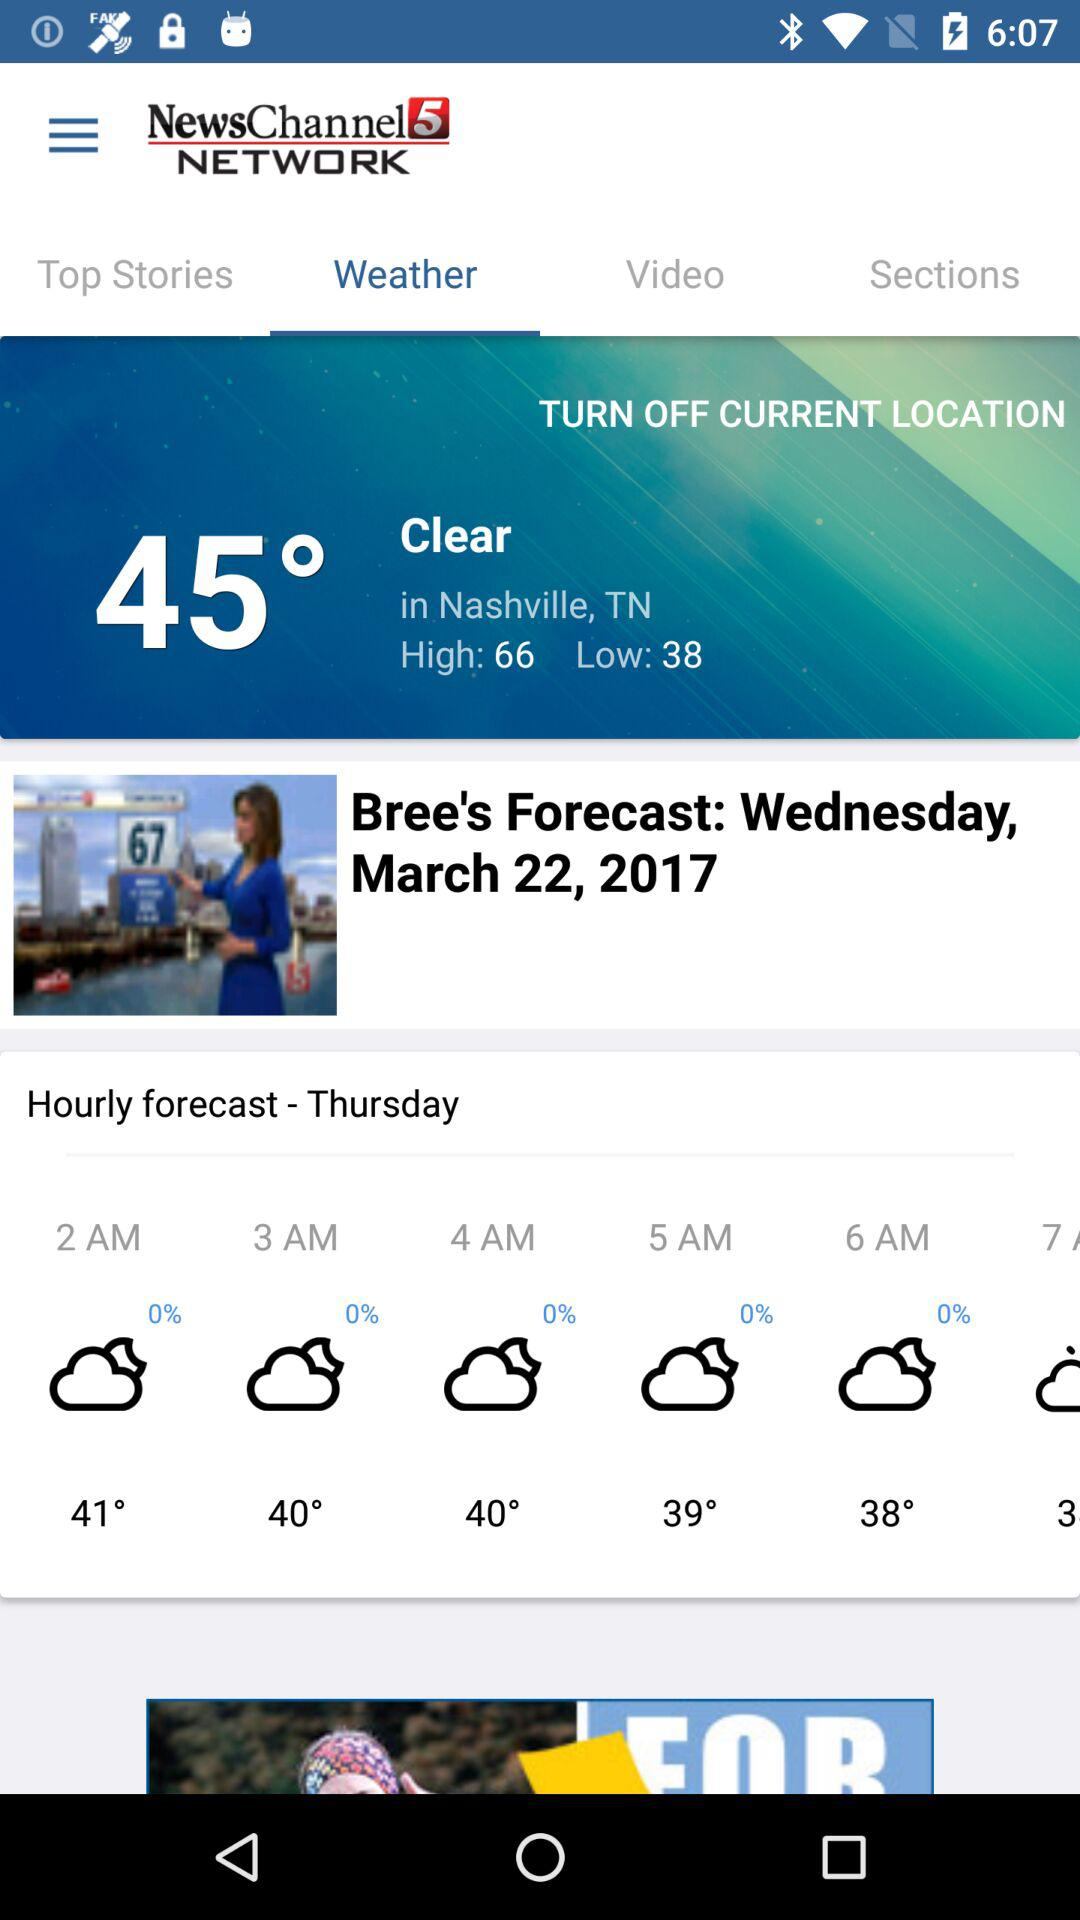What is the day? The day is Wednesday. 